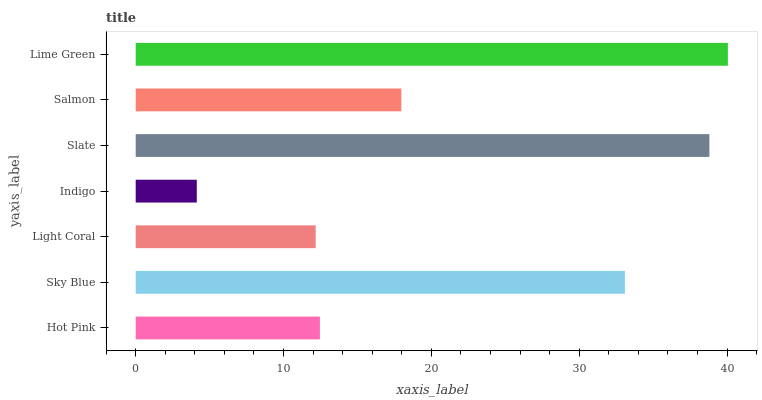Is Indigo the minimum?
Answer yes or no. Yes. Is Lime Green the maximum?
Answer yes or no. Yes. Is Sky Blue the minimum?
Answer yes or no. No. Is Sky Blue the maximum?
Answer yes or no. No. Is Sky Blue greater than Hot Pink?
Answer yes or no. Yes. Is Hot Pink less than Sky Blue?
Answer yes or no. Yes. Is Hot Pink greater than Sky Blue?
Answer yes or no. No. Is Sky Blue less than Hot Pink?
Answer yes or no. No. Is Salmon the high median?
Answer yes or no. Yes. Is Salmon the low median?
Answer yes or no. Yes. Is Slate the high median?
Answer yes or no. No. Is Lime Green the low median?
Answer yes or no. No. 